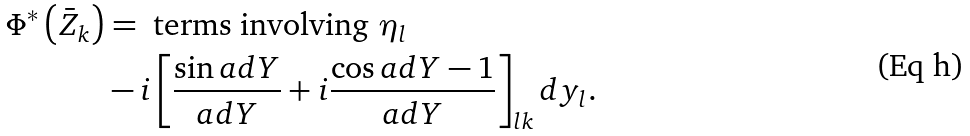Convert formula to latex. <formula><loc_0><loc_0><loc_500><loc_500>\Phi ^ { \ast } \left ( \bar { Z } _ { k } \right ) & = \text { terms involving } \eta _ { l } \\ & - i \left [ \frac { \sin a d Y } { a d Y } + i \frac { \cos a d Y - 1 } { a d Y } \right ] _ { l k } d y _ { l } .</formula> 